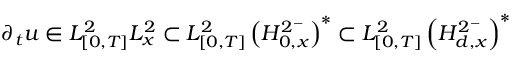<formula> <loc_0><loc_0><loc_500><loc_500>\partial _ { t } u \in L _ { [ 0 , T ] } ^ { 2 } L _ { x } ^ { 2 } \subset L _ { [ 0 , T ] } ^ { 2 } \left ( H _ { 0 , x } ^ { 2 ^ { - } } \right ) ^ { * } \subset L _ { [ 0 , T ] } ^ { 2 } \left ( H _ { d , x } ^ { 2 ^ { - } } \right ) ^ { * }</formula> 